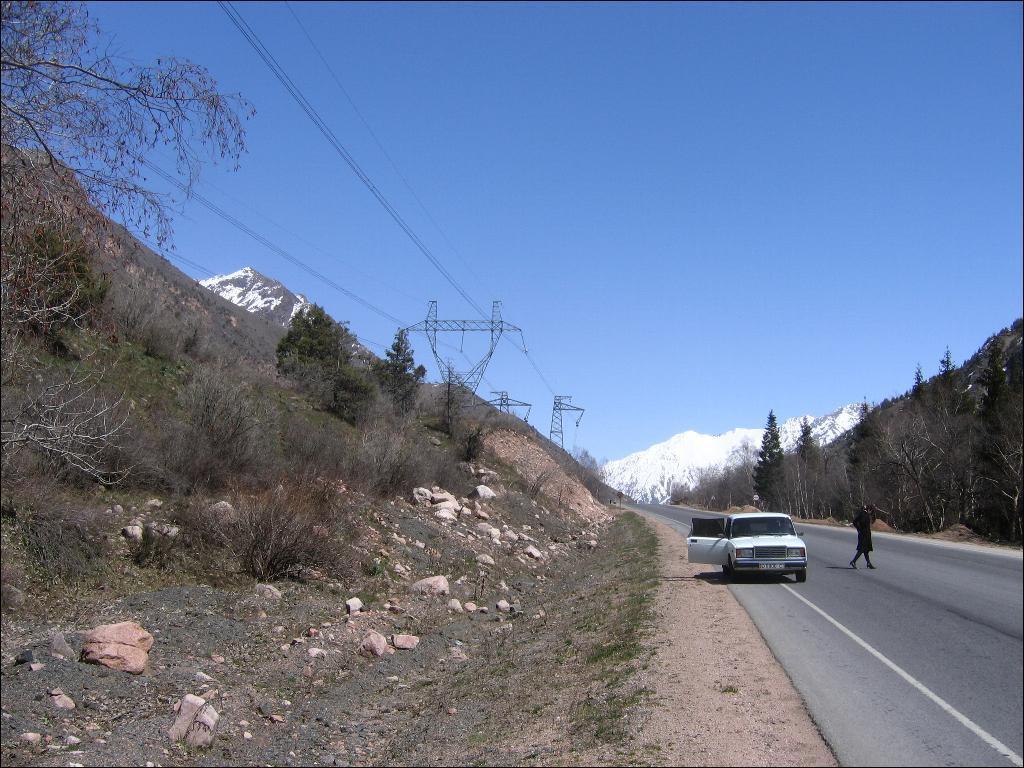Please provide a concise description of this image. In this image there is a vehicle parked on the road and there is a person walking. On the left and right side of the image there are trees and mountains. On the left side of the image there are a few towers and cables are connected to it. In the background there is the sky. 